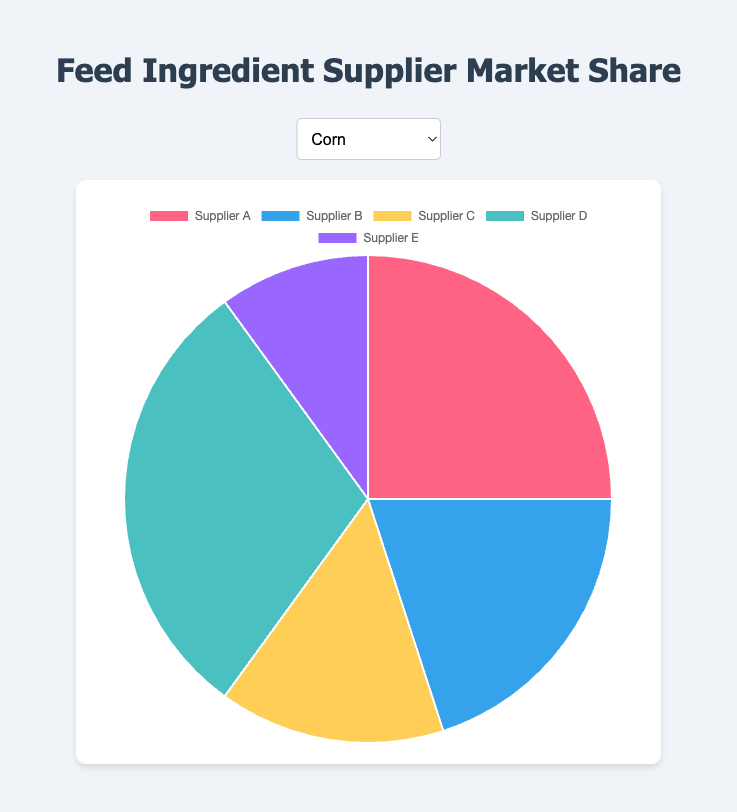Which supplier holds the largest market share for Corn? The segment labeled "Supplier D" occupies the largest portion of the pie chart for Corn.
Answer: Supplier D Which supplier has the smallest market share for Soybean Meal? The segment labeled "Supplier E" is the smallest in the pie chart for Soybean Meal.
Answer: Supplier E What is the total market share percentage of Suppliers A and B for Fish Meal? The market share for Supplier A is 30%, and for Supplier B, it is 15%. Adding them together: 30% + 15% = 45%.
Answer: 45% For Wheat Bran, how do the market shares of Suppliers C and D compare? The pie chart shows that both Suppliers C and D have identical market shares of 15% for Wheat Bran.
Answer: Equal What is the combined market share of the top three suppliers for Rice Bran? The top three suppliers are determined by their respective market shares. Supplier D has 25%, while Suppliers A, B, and C each have 20%. Adding the shares of Supplier D, A, and B or C: 25% + 20% + 20% = 65%.
Answer: 65% Which ingredient has the highest market share percentage for Supplier A? Reviewing each pie chart, Wheat Bran shows Supplier A's segment is the largest at 35%.
Answer: Wheat Bran Visually, which supplier has the smallest segment in the Corn market share pie chart? The smallest segment is represented by Supplier E's portion, which is 10%.
Answer: Supplier E How does the market share of Supplier C for Corn compare to that of Supplier B for Corn? Supplier C has a 15% market share, while Supplier B holds a 20% market share in the Corn market. Supplier B’s share is larger.
Answer: Supplier B has a larger share For Soybean Meal, how much larger is the market share of Supplier D compared to Supplier E? Supplier D has a 25% market share, and Supplier E has 15%. Subtracting Supplier E's share from Supplier D's: 25% - 15% = 10%.
Answer: 10% By how much does Supplier A’s market share for Fish Meal exceed Supplier D’s market share for the same ingredient? Supplier A’s market share for Fish Meal is 30%, and Supplier D’s is 10%. The difference in their shares is 30% - 10% = 20%.
Answer: 20% 